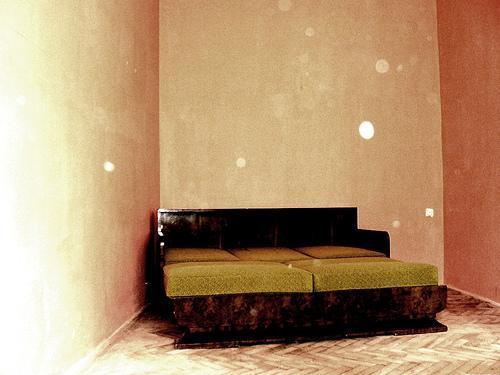How many cushions are present?
Give a very brief answer. 5. 